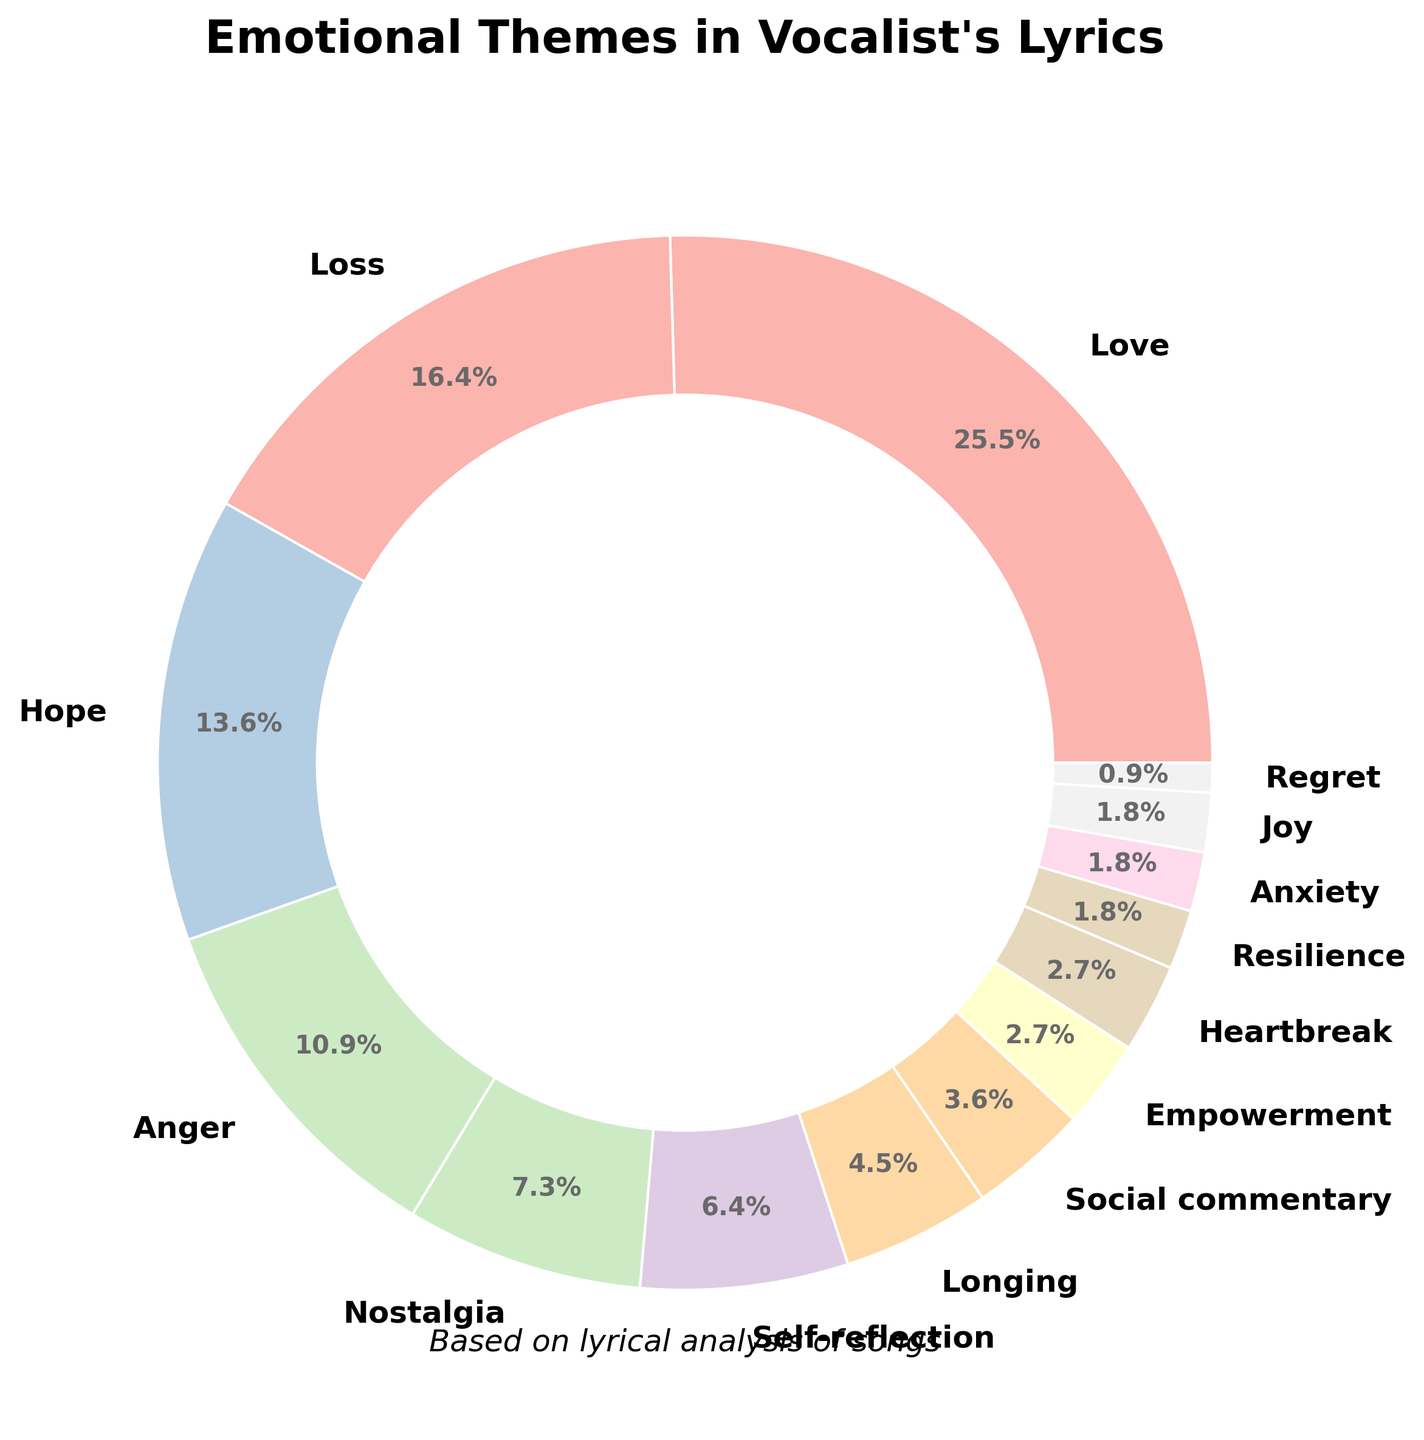What emotional theme has the highest representation in the vocalist's lyrics? From the pie chart, the largest slice of the pie is labeled 'Love' with 28%. Therefore, 'Love' has the highest representation.
Answer: Love Which two themes combined make up nearly half of the lyrics' emotional themes? To find which themes combined make up nearly half, we need to look for two themes whose percentages sum close to 50%. 'Love' (28%) and 'Loss' (18%) combined make 46%, which is the closest to 50%.
Answer: Love and Loss How much more prevalent is 'Hope' compared to 'Nostalgia'? 'Hope' accounts for 15% and 'Nostalgia' for 8%. The difference is calculated as 15% - 8%, giving 7% more prevalence for 'Hope'.
Answer: 7% What is the combined percentage of the least represented themes in the vocalist's lyrics? The themes with the smallest percentages are 'Resilience' (2%), 'Anxiety' (2%), 'Joy' (2%), and 'Regret' (1%). Adding them together, we get 2% + 2% + 2% + 1% = 7%.
Answer: 7% Is 'Empowerment' more or less prevalent than 'Social commentary' in the lyrics? 'Empowerment' has a 3% representation, while 'Social commentary' has a 4% representation, making 'Empowerment' less prevalent.
Answer: Less What portion of the lyrics is represented by themes other than 'Love', 'Loss', and 'Hope'? 'Love', 'Loss', and 'Hope' make up 28% + 18% + 15% = 61%. Therefore, the remaining portion is 100% - 61% = 39%.
Answer: 39% How many themes are represented by exactly 2% in the pie chart? Identifying all slices labeled 2%, 'Resilience', 'Anxiety', and 'Joy' each represent 2%, counted as three themes.
Answer: 3 By what percentage does 'Self-reflection' exceed 'Longing'? 'Self-reflection' represents 7% while 'Longing' represents 5%. The difference is calculated as 7% - 5% = 2%.
Answer: 2% Which is the least represented emotion in the lyrics? The smallest slice in the pie chart is labeled 'Regret' with 1%. So, 'Regret' is the least represented emotion.
Answer: Regret What is the visual significance of the largest slice of the pie chart? The largest slice, representing 'Love' with 28%, visually suggests that 'Love' is the dominant emotional theme in the vocalist's lyrics, being the most prevalent by proportion.
Answer: Represents the dominance of 'Love' 